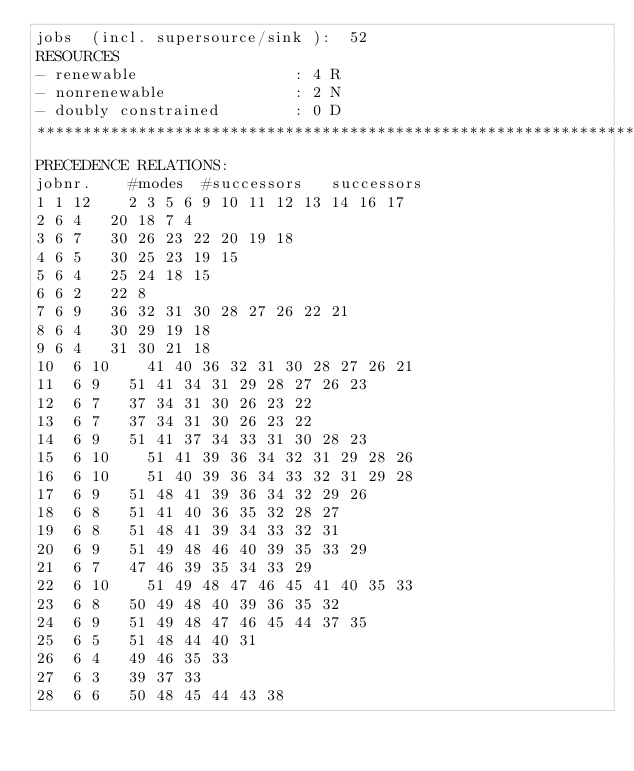<code> <loc_0><loc_0><loc_500><loc_500><_ObjectiveC_>jobs  (incl. supersource/sink ):	52
RESOURCES
- renewable                 : 4 R
- nonrenewable              : 2 N
- doubly constrained        : 0 D
************************************************************************
PRECEDENCE RELATIONS:
jobnr.    #modes  #successors   successors
1	1	12		2 3 5 6 9 10 11 12 13 14 16 17 
2	6	4		20 18 7 4 
3	6	7		30 26 23 22 20 19 18 
4	6	5		30 25 23 19 15 
5	6	4		25 24 18 15 
6	6	2		22 8 
7	6	9		36 32 31 30 28 27 26 22 21 
8	6	4		30 29 19 18 
9	6	4		31 30 21 18 
10	6	10		41 40 36 32 31 30 28 27 26 21 
11	6	9		51 41 34 31 29 28 27 26 23 
12	6	7		37 34 31 30 26 23 22 
13	6	7		37 34 31 30 26 23 22 
14	6	9		51 41 37 34 33 31 30 28 23 
15	6	10		51 41 39 36 34 32 31 29 28 26 
16	6	10		51 40 39 36 34 33 32 31 29 28 
17	6	9		51 48 41 39 36 34 32 29 26 
18	6	8		51 41 40 36 35 32 28 27 
19	6	8		51 48 41 39 34 33 32 31 
20	6	9		51 49 48 46 40 39 35 33 29 
21	6	7		47 46 39 35 34 33 29 
22	6	10		51 49 48 47 46 45 41 40 35 33 
23	6	8		50 49 48 40 39 36 35 32 
24	6	9		51 49 48 47 46 45 44 37 35 
25	6	5		51 48 44 40 31 
26	6	4		49 46 35 33 
27	6	3		39 37 33 
28	6	6		50 48 45 44 43 38 </code> 